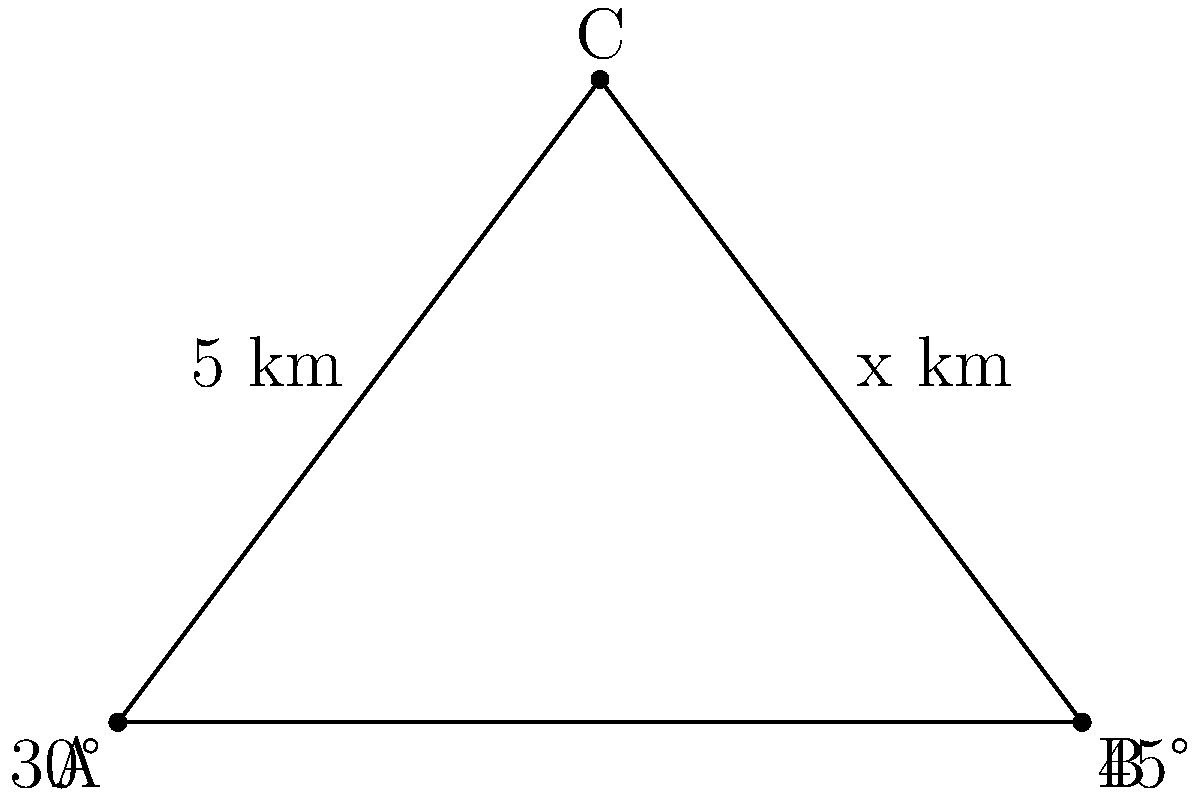Three radar stations A, B, and C are positioned along a coastline to combat piracy. Station A is 6 km east of station B, and station C is north of the line connecting A and B. The angle between the coastline (AB) and the line from A to C is 30°, while the angle between AB and BC is 45°. If the distance between A and C is 5 km, what is the distance (x) between B and C? Let's solve this step-by-step:

1) First, we can see that triangle ABC is formed by the three radar stations.

2) We know that:
   - AB = 6 km
   - AC = 5 km
   - Angle CAB = 30°
   - Angle CBA = 45°

3) To find BC (x), we can use the law of cosines:

   $$BC^2 = AB^2 + AC^2 - 2(AB)(AC)\cos(\angle BAC)$$

4) We need to find angle BAC. We know that:
   - Angle CAB = 30°
   - Angle CBA = 45°
   - The sum of angles in a triangle is 180°

   So, $$\angle BAC = 180° - (30° + 45°) = 105°$$

5) Now we can plug everything into the law of cosines:

   $$x^2 = 6^2 + 5^2 - 2(6)(5)\cos(105°)$$

6) Simplify:
   $$x^2 = 36 + 25 - 60\cos(105°)$$
   $$x^2 = 61 + 60(-0.2588) = 61 - 15.528 = 45.472$$

7) Take the square root of both sides:
   $$x = \sqrt{45.472} \approx 6.74$$

Therefore, the distance between B and C is approximately 6.74 km.
Answer: 6.74 km 